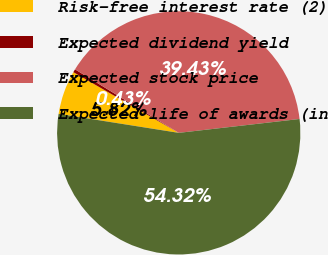Convert chart. <chart><loc_0><loc_0><loc_500><loc_500><pie_chart><fcel>Risk-free interest rate (2)<fcel>Expected dividend yield<fcel>Expected stock price<fcel>Expected life of awards (in<nl><fcel>5.82%<fcel>0.43%<fcel>39.43%<fcel>54.31%<nl></chart> 